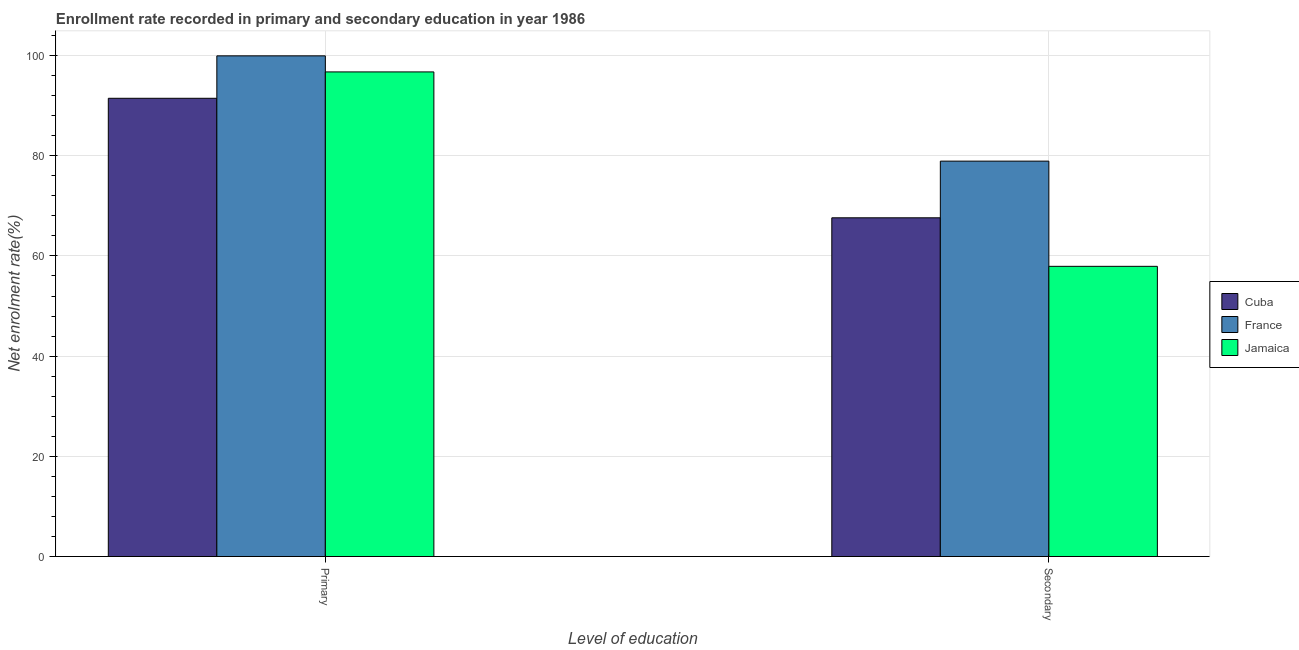How many different coloured bars are there?
Provide a succinct answer. 3. How many groups of bars are there?
Offer a terse response. 2. How many bars are there on the 1st tick from the right?
Offer a very short reply. 3. What is the label of the 2nd group of bars from the left?
Keep it short and to the point. Secondary. What is the enrollment rate in secondary education in Cuba?
Provide a succinct answer. 67.61. Across all countries, what is the maximum enrollment rate in secondary education?
Provide a succinct answer. 78.92. Across all countries, what is the minimum enrollment rate in primary education?
Keep it short and to the point. 91.46. In which country was the enrollment rate in primary education minimum?
Keep it short and to the point. Cuba. What is the total enrollment rate in primary education in the graph?
Offer a terse response. 288.12. What is the difference between the enrollment rate in secondary education in Jamaica and that in France?
Keep it short and to the point. -21. What is the difference between the enrollment rate in primary education in France and the enrollment rate in secondary education in Jamaica?
Your response must be concise. 42.01. What is the average enrollment rate in secondary education per country?
Make the answer very short. 68.15. What is the difference between the enrollment rate in primary education and enrollment rate in secondary education in Cuba?
Your answer should be very brief. 23.86. In how many countries, is the enrollment rate in primary education greater than 8 %?
Your response must be concise. 3. What is the ratio of the enrollment rate in secondary education in Jamaica to that in France?
Keep it short and to the point. 0.73. In how many countries, is the enrollment rate in secondary education greater than the average enrollment rate in secondary education taken over all countries?
Keep it short and to the point. 1. What does the 2nd bar from the left in Primary represents?
Provide a succinct answer. France. What does the 3rd bar from the right in Primary represents?
Give a very brief answer. Cuba. Are all the bars in the graph horizontal?
Your response must be concise. No. How many countries are there in the graph?
Make the answer very short. 3. What is the difference between two consecutive major ticks on the Y-axis?
Ensure brevity in your answer.  20. Are the values on the major ticks of Y-axis written in scientific E-notation?
Keep it short and to the point. No. Where does the legend appear in the graph?
Make the answer very short. Center right. What is the title of the graph?
Offer a very short reply. Enrollment rate recorded in primary and secondary education in year 1986. What is the label or title of the X-axis?
Provide a short and direct response. Level of education. What is the label or title of the Y-axis?
Give a very brief answer. Net enrolment rate(%). What is the Net enrolment rate(%) in Cuba in Primary?
Ensure brevity in your answer.  91.46. What is the Net enrolment rate(%) of France in Primary?
Give a very brief answer. 99.93. What is the Net enrolment rate(%) of Jamaica in Primary?
Offer a very short reply. 96.73. What is the Net enrolment rate(%) of Cuba in Secondary?
Offer a very short reply. 67.61. What is the Net enrolment rate(%) of France in Secondary?
Give a very brief answer. 78.92. What is the Net enrolment rate(%) in Jamaica in Secondary?
Give a very brief answer. 57.92. Across all Level of education, what is the maximum Net enrolment rate(%) in Cuba?
Offer a very short reply. 91.46. Across all Level of education, what is the maximum Net enrolment rate(%) in France?
Offer a very short reply. 99.93. Across all Level of education, what is the maximum Net enrolment rate(%) in Jamaica?
Your answer should be very brief. 96.73. Across all Level of education, what is the minimum Net enrolment rate(%) of Cuba?
Your response must be concise. 67.61. Across all Level of education, what is the minimum Net enrolment rate(%) in France?
Your response must be concise. 78.92. Across all Level of education, what is the minimum Net enrolment rate(%) of Jamaica?
Your response must be concise. 57.92. What is the total Net enrolment rate(%) in Cuba in the graph?
Provide a succinct answer. 159.07. What is the total Net enrolment rate(%) of France in the graph?
Offer a terse response. 178.85. What is the total Net enrolment rate(%) in Jamaica in the graph?
Keep it short and to the point. 154.65. What is the difference between the Net enrolment rate(%) in Cuba in Primary and that in Secondary?
Your response must be concise. 23.86. What is the difference between the Net enrolment rate(%) of France in Primary and that in Secondary?
Keep it short and to the point. 21.01. What is the difference between the Net enrolment rate(%) of Jamaica in Primary and that in Secondary?
Give a very brief answer. 38.81. What is the difference between the Net enrolment rate(%) of Cuba in Primary and the Net enrolment rate(%) of France in Secondary?
Keep it short and to the point. 12.54. What is the difference between the Net enrolment rate(%) in Cuba in Primary and the Net enrolment rate(%) in Jamaica in Secondary?
Keep it short and to the point. 33.54. What is the difference between the Net enrolment rate(%) in France in Primary and the Net enrolment rate(%) in Jamaica in Secondary?
Keep it short and to the point. 42.01. What is the average Net enrolment rate(%) of Cuba per Level of education?
Keep it short and to the point. 79.54. What is the average Net enrolment rate(%) of France per Level of education?
Offer a very short reply. 89.43. What is the average Net enrolment rate(%) in Jamaica per Level of education?
Your answer should be compact. 77.32. What is the difference between the Net enrolment rate(%) of Cuba and Net enrolment rate(%) of France in Primary?
Keep it short and to the point. -8.47. What is the difference between the Net enrolment rate(%) of Cuba and Net enrolment rate(%) of Jamaica in Primary?
Keep it short and to the point. -5.26. What is the difference between the Net enrolment rate(%) in France and Net enrolment rate(%) in Jamaica in Primary?
Your response must be concise. 3.21. What is the difference between the Net enrolment rate(%) in Cuba and Net enrolment rate(%) in France in Secondary?
Provide a short and direct response. -11.31. What is the difference between the Net enrolment rate(%) in Cuba and Net enrolment rate(%) in Jamaica in Secondary?
Offer a very short reply. 9.69. What is the difference between the Net enrolment rate(%) of France and Net enrolment rate(%) of Jamaica in Secondary?
Ensure brevity in your answer.  21. What is the ratio of the Net enrolment rate(%) in Cuba in Primary to that in Secondary?
Provide a short and direct response. 1.35. What is the ratio of the Net enrolment rate(%) of France in Primary to that in Secondary?
Provide a succinct answer. 1.27. What is the ratio of the Net enrolment rate(%) in Jamaica in Primary to that in Secondary?
Your response must be concise. 1.67. What is the difference between the highest and the second highest Net enrolment rate(%) of Cuba?
Provide a short and direct response. 23.86. What is the difference between the highest and the second highest Net enrolment rate(%) in France?
Keep it short and to the point. 21.01. What is the difference between the highest and the second highest Net enrolment rate(%) of Jamaica?
Make the answer very short. 38.81. What is the difference between the highest and the lowest Net enrolment rate(%) in Cuba?
Provide a succinct answer. 23.86. What is the difference between the highest and the lowest Net enrolment rate(%) in France?
Offer a very short reply. 21.01. What is the difference between the highest and the lowest Net enrolment rate(%) of Jamaica?
Your response must be concise. 38.81. 